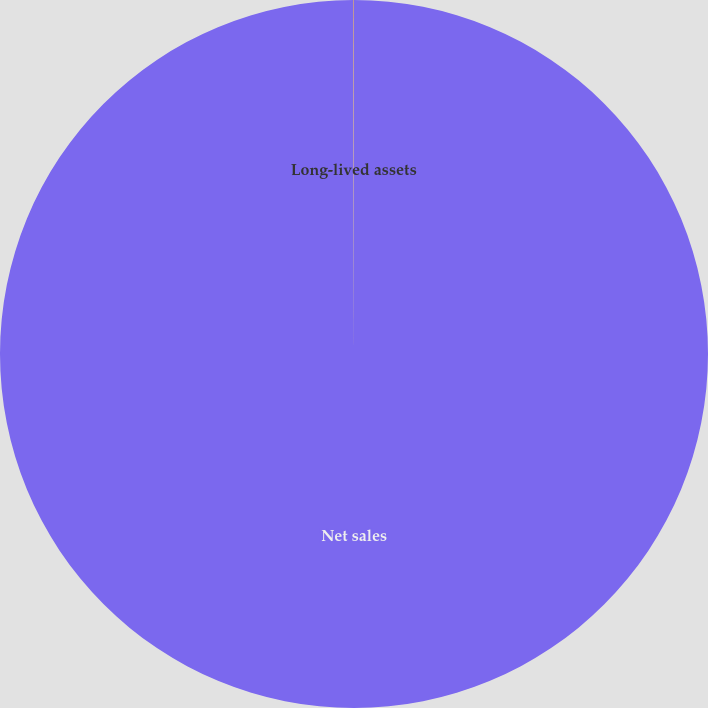<chart> <loc_0><loc_0><loc_500><loc_500><pie_chart><fcel>Net sales<fcel>Long-lived assets<nl><fcel>99.96%<fcel>0.04%<nl></chart> 